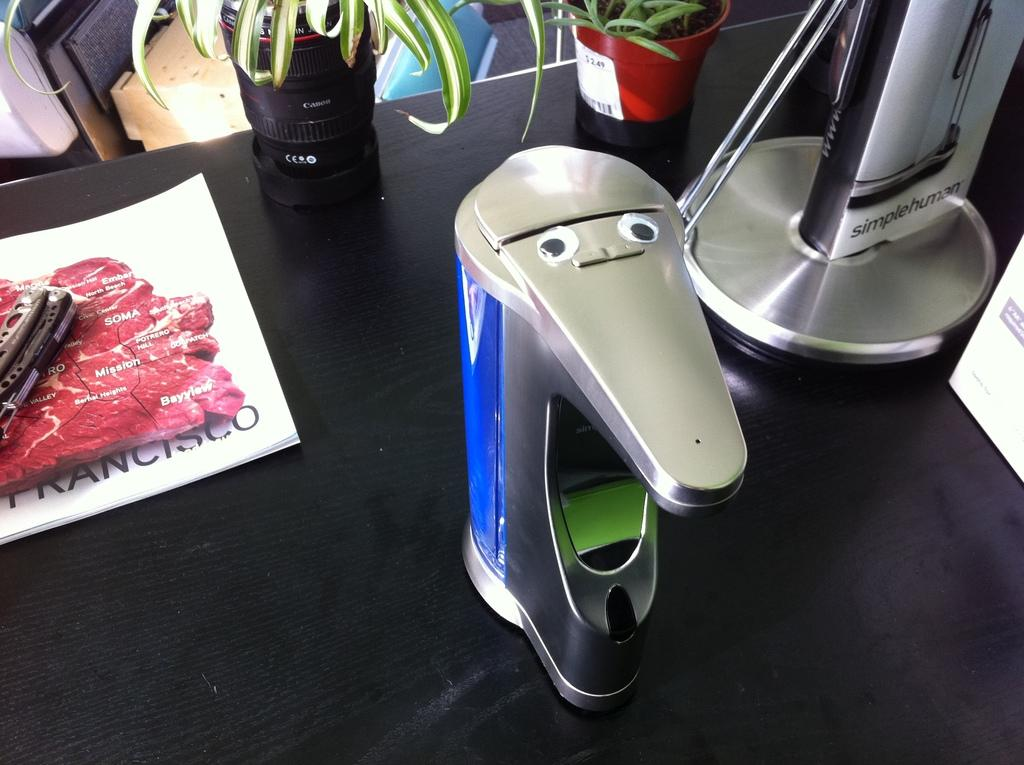<image>
Render a clear and concise summary of the photo. A silver device next to another tall silver device with the name Simplehuman. 